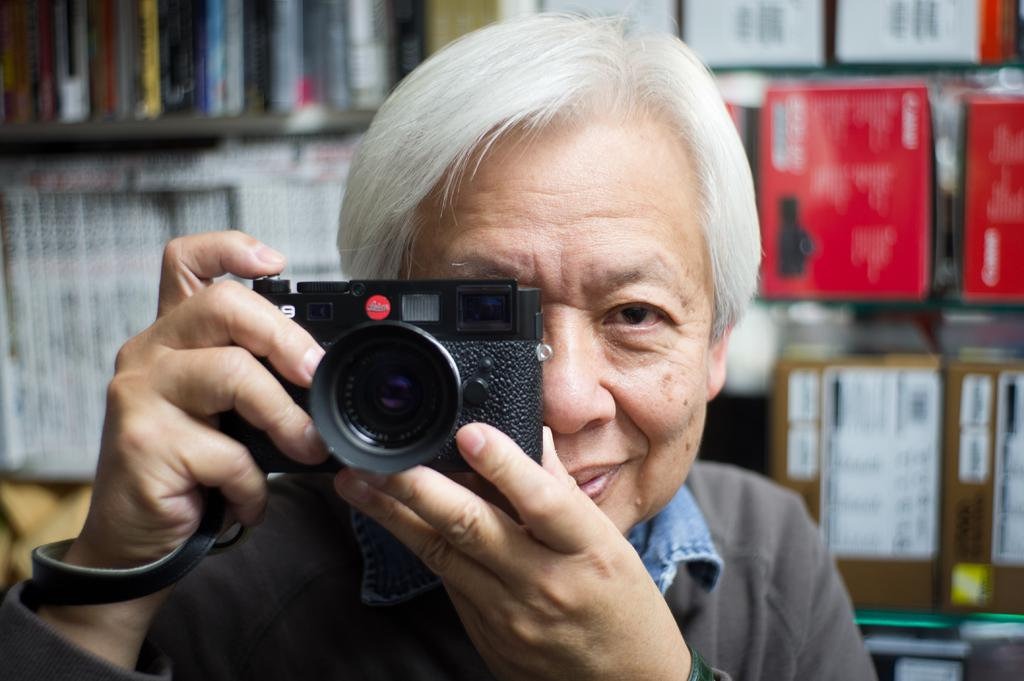Who is the main subject in the image? There is a man in the image. What is the man holding in his hands? The man is holding a camera in his hands. What expression does the man have on his face? The man is smiling. What can be seen in the background of the image? There is a shelf visible in the background of the image. What is on the shelf? There are objects on the shelf. What type of trees can be seen growing on the shelf in the image? There are no trees visible on the shelf in the image; it contains objects. What is the shelf made of, and is it made of wax? The material of the shelf is not mentioned in the image, and there is no indication that it is made of wax. 